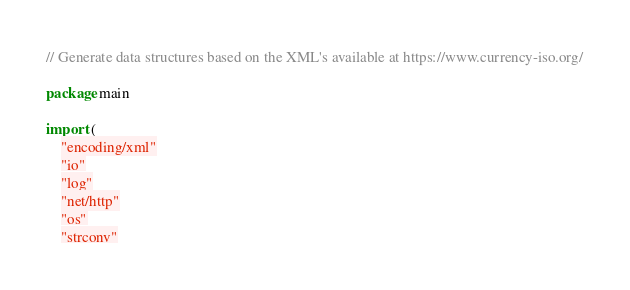<code> <loc_0><loc_0><loc_500><loc_500><_Go_>// Generate data structures based on the XML's available at https://www.currency-iso.org/

package main

import (
	"encoding/xml"
	"io"
	"log"
	"net/http"
	"os"
	"strconv"</code> 